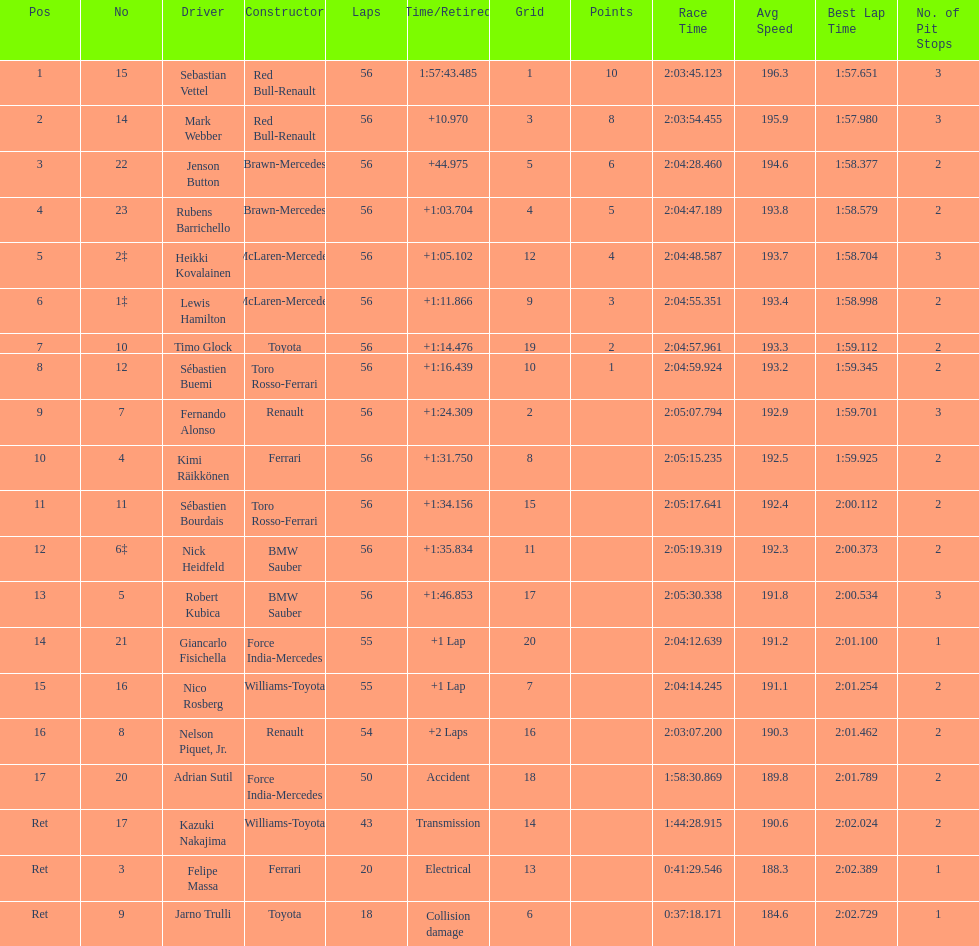What was jenson button's time? +44.975. 